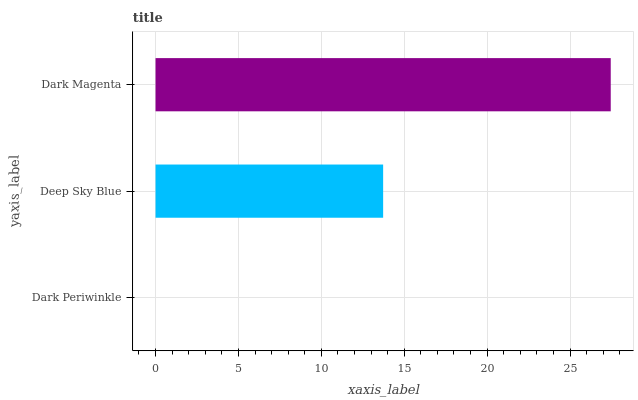Is Dark Periwinkle the minimum?
Answer yes or no. Yes. Is Dark Magenta the maximum?
Answer yes or no. Yes. Is Deep Sky Blue the minimum?
Answer yes or no. No. Is Deep Sky Blue the maximum?
Answer yes or no. No. Is Deep Sky Blue greater than Dark Periwinkle?
Answer yes or no. Yes. Is Dark Periwinkle less than Deep Sky Blue?
Answer yes or no. Yes. Is Dark Periwinkle greater than Deep Sky Blue?
Answer yes or no. No. Is Deep Sky Blue less than Dark Periwinkle?
Answer yes or no. No. Is Deep Sky Blue the high median?
Answer yes or no. Yes. Is Deep Sky Blue the low median?
Answer yes or no. Yes. Is Dark Magenta the high median?
Answer yes or no. No. Is Dark Magenta the low median?
Answer yes or no. No. 